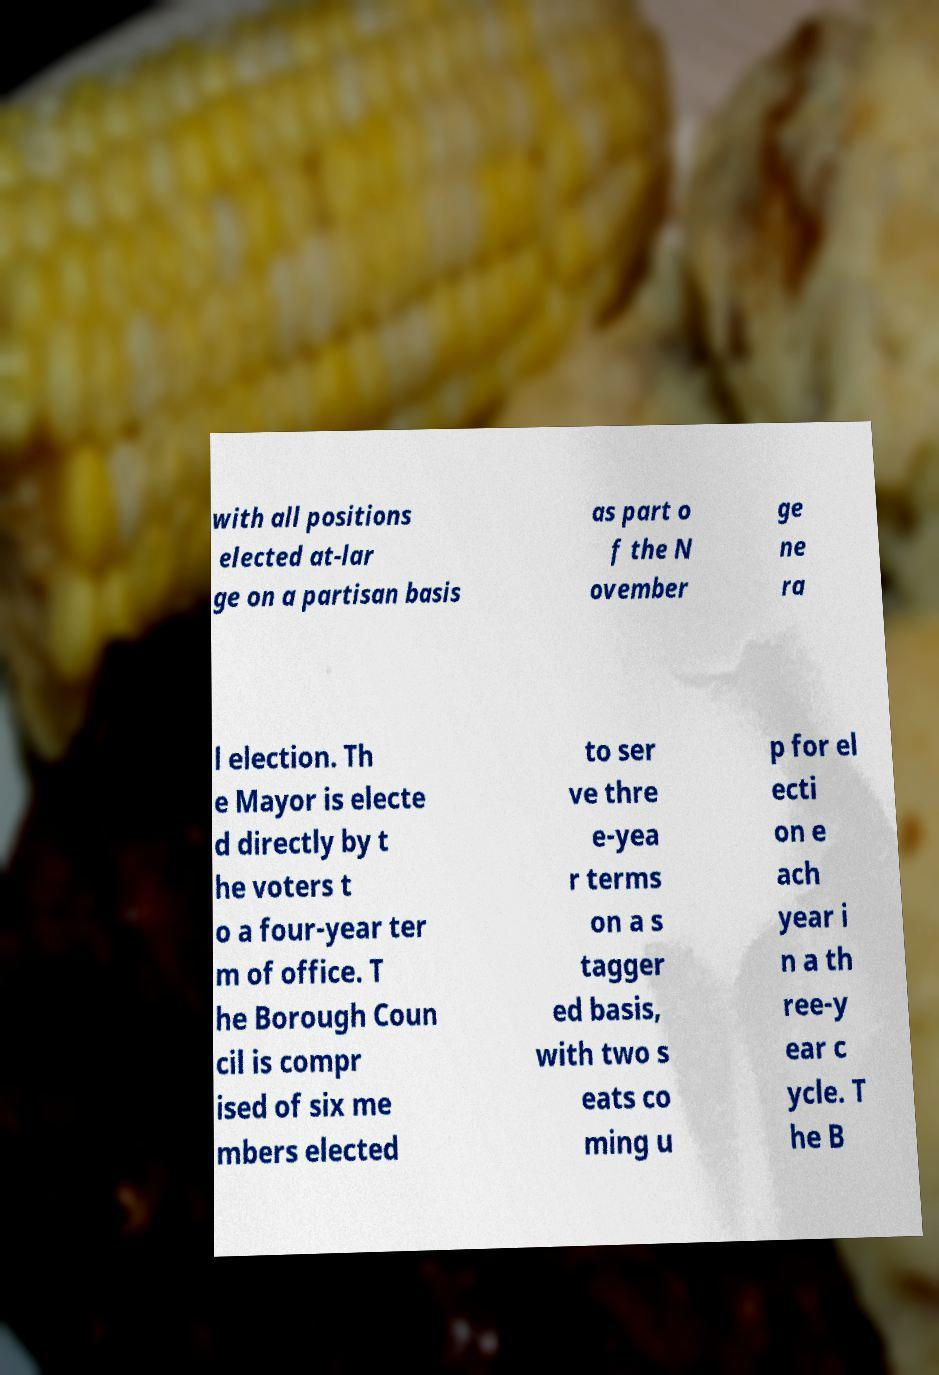Can you read and provide the text displayed in the image?This photo seems to have some interesting text. Can you extract and type it out for me? with all positions elected at-lar ge on a partisan basis as part o f the N ovember ge ne ra l election. Th e Mayor is electe d directly by t he voters t o a four-year ter m of office. T he Borough Coun cil is compr ised of six me mbers elected to ser ve thre e-yea r terms on a s tagger ed basis, with two s eats co ming u p for el ecti on e ach year i n a th ree-y ear c ycle. T he B 